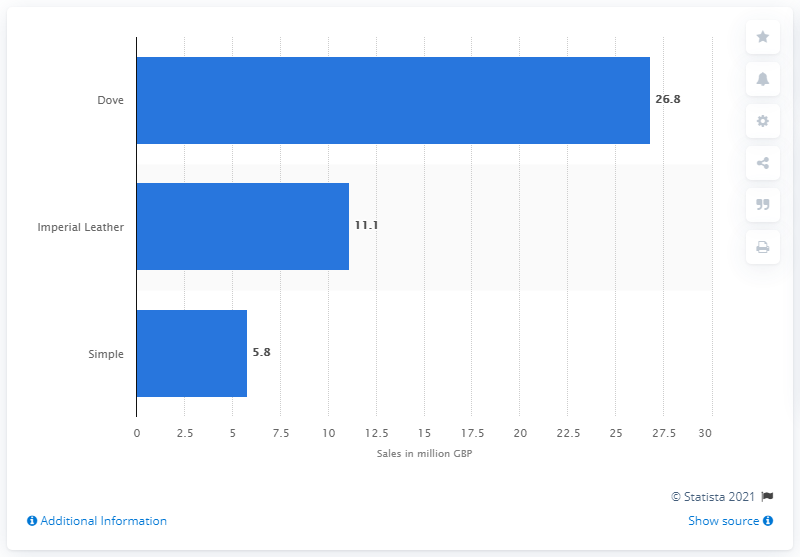Specify some key components in this picture. According to reliable sources, Dove is the top-selling bar soap brand in the United Kingdom. In the year ending December 2014, Dove generated approximately 26.8 million dollars in sales. 